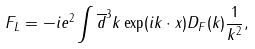Convert formula to latex. <formula><loc_0><loc_0><loc_500><loc_500>F _ { L } = - i e ^ { 2 } \int \overline { d } ^ { 3 } k \exp ( i k \cdot x ) D _ { F } ( k ) \frac { 1 } { k ^ { 2 } } ,</formula> 